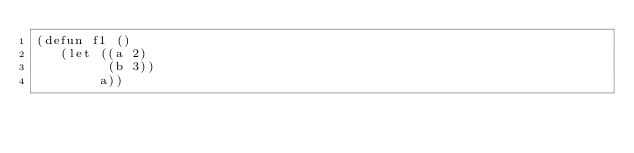Convert code to text. <code><loc_0><loc_0><loc_500><loc_500><_Lisp_>(defun f1 ()
   (let ((a 2) 
         (b 3)) 
        a))</code> 